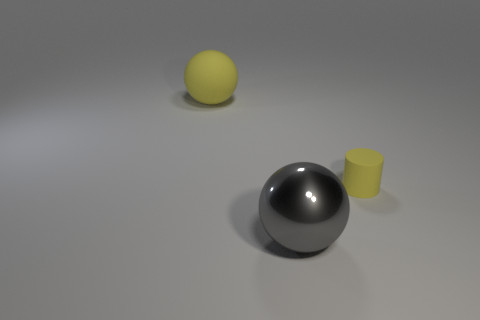Add 3 shiny blocks. How many objects exist? 6 Subtract all spheres. How many objects are left? 1 Add 3 big gray shiny objects. How many big gray shiny objects exist? 4 Subtract 0 purple balls. How many objects are left? 3 Subtract all large rubber objects. Subtract all rubber cylinders. How many objects are left? 1 Add 1 big objects. How many big objects are left? 3 